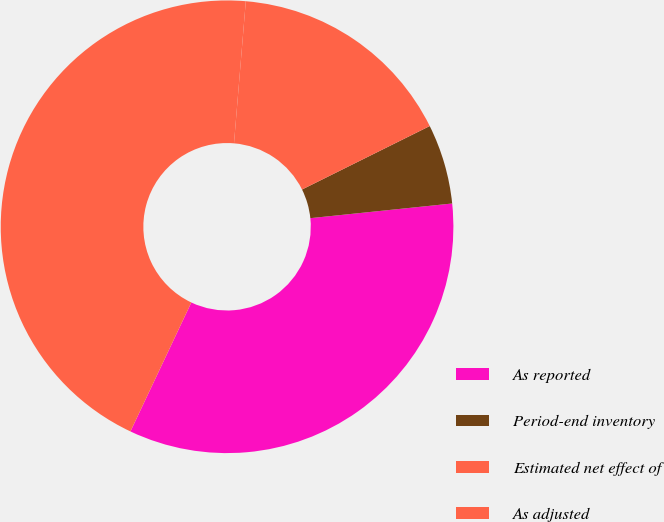<chart> <loc_0><loc_0><loc_500><loc_500><pie_chart><fcel>As reported<fcel>Period-end inventory<fcel>Estimated net effect of<fcel>As adjusted<nl><fcel>33.66%<fcel>5.7%<fcel>16.34%<fcel>44.3%<nl></chart> 